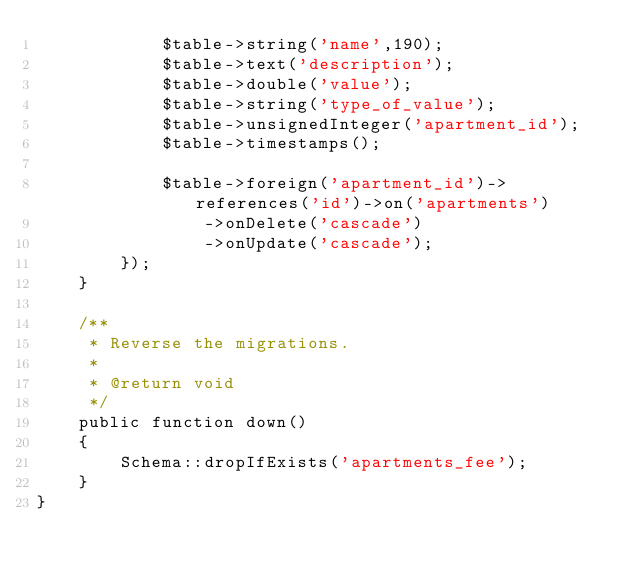Convert code to text. <code><loc_0><loc_0><loc_500><loc_500><_PHP_>            $table->string('name',190);
            $table->text('description');
            $table->double('value');
            $table->string('type_of_value');
            $table->unsignedInteger('apartment_id');
            $table->timestamps();

            $table->foreign('apartment_id')->references('id')->on('apartments')
                ->onDelete('cascade')
                ->onUpdate('cascade');
        });
    }

    /**
     * Reverse the migrations.
     *
     * @return void
     */
    public function down()
    {
        Schema::dropIfExists('apartments_fee');
    }
}
</code> 